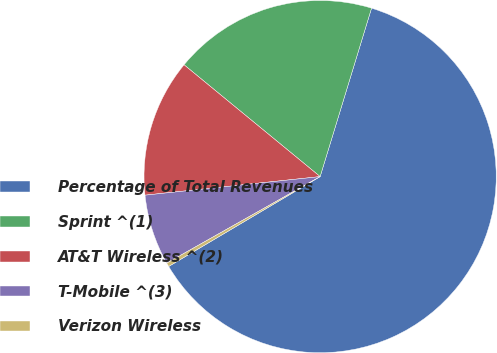Convert chart to OTSL. <chart><loc_0><loc_0><loc_500><loc_500><pie_chart><fcel>Percentage of Total Revenues<fcel>Sprint ^(1)<fcel>AT&T Wireless ^(2)<fcel>T-Mobile ^(3)<fcel>Verizon Wireless<nl><fcel>61.76%<fcel>18.77%<fcel>12.63%<fcel>6.49%<fcel>0.35%<nl></chart> 